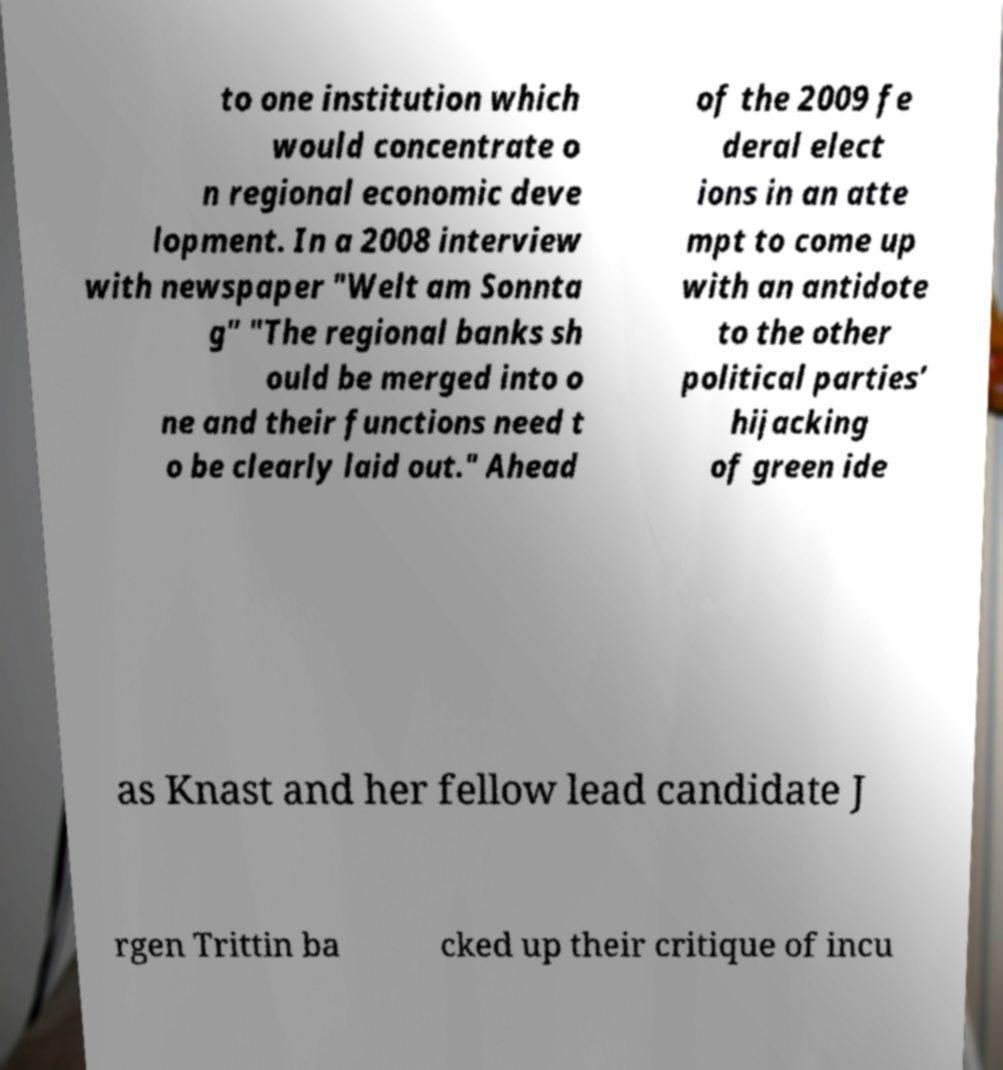Can you read and provide the text displayed in the image?This photo seems to have some interesting text. Can you extract and type it out for me? to one institution which would concentrate o n regional economic deve lopment. In a 2008 interview with newspaper "Welt am Sonnta g" "The regional banks sh ould be merged into o ne and their functions need t o be clearly laid out." Ahead of the 2009 fe deral elect ions in an atte mpt to come up with an antidote to the other political parties’ hijacking of green ide as Knast and her fellow lead candidate J rgen Trittin ba cked up their critique of incu 